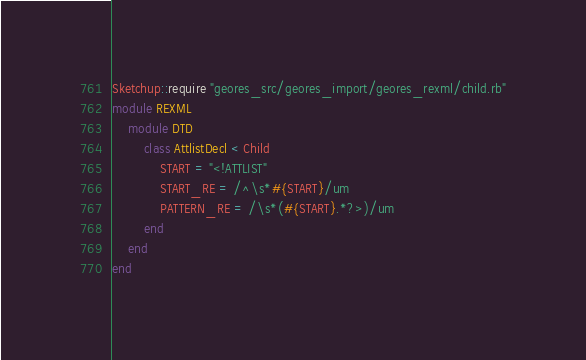<code> <loc_0><loc_0><loc_500><loc_500><_Ruby_>Sketchup::require "geores_src/geores_import/geores_rexml/child.rb"
module REXML
	module DTD
		class AttlistDecl < Child
			START = "<!ATTLIST"
			START_RE = /^\s*#{START}/um
			PATTERN_RE = /\s*(#{START}.*?>)/um
		end
	end
end
</code> 